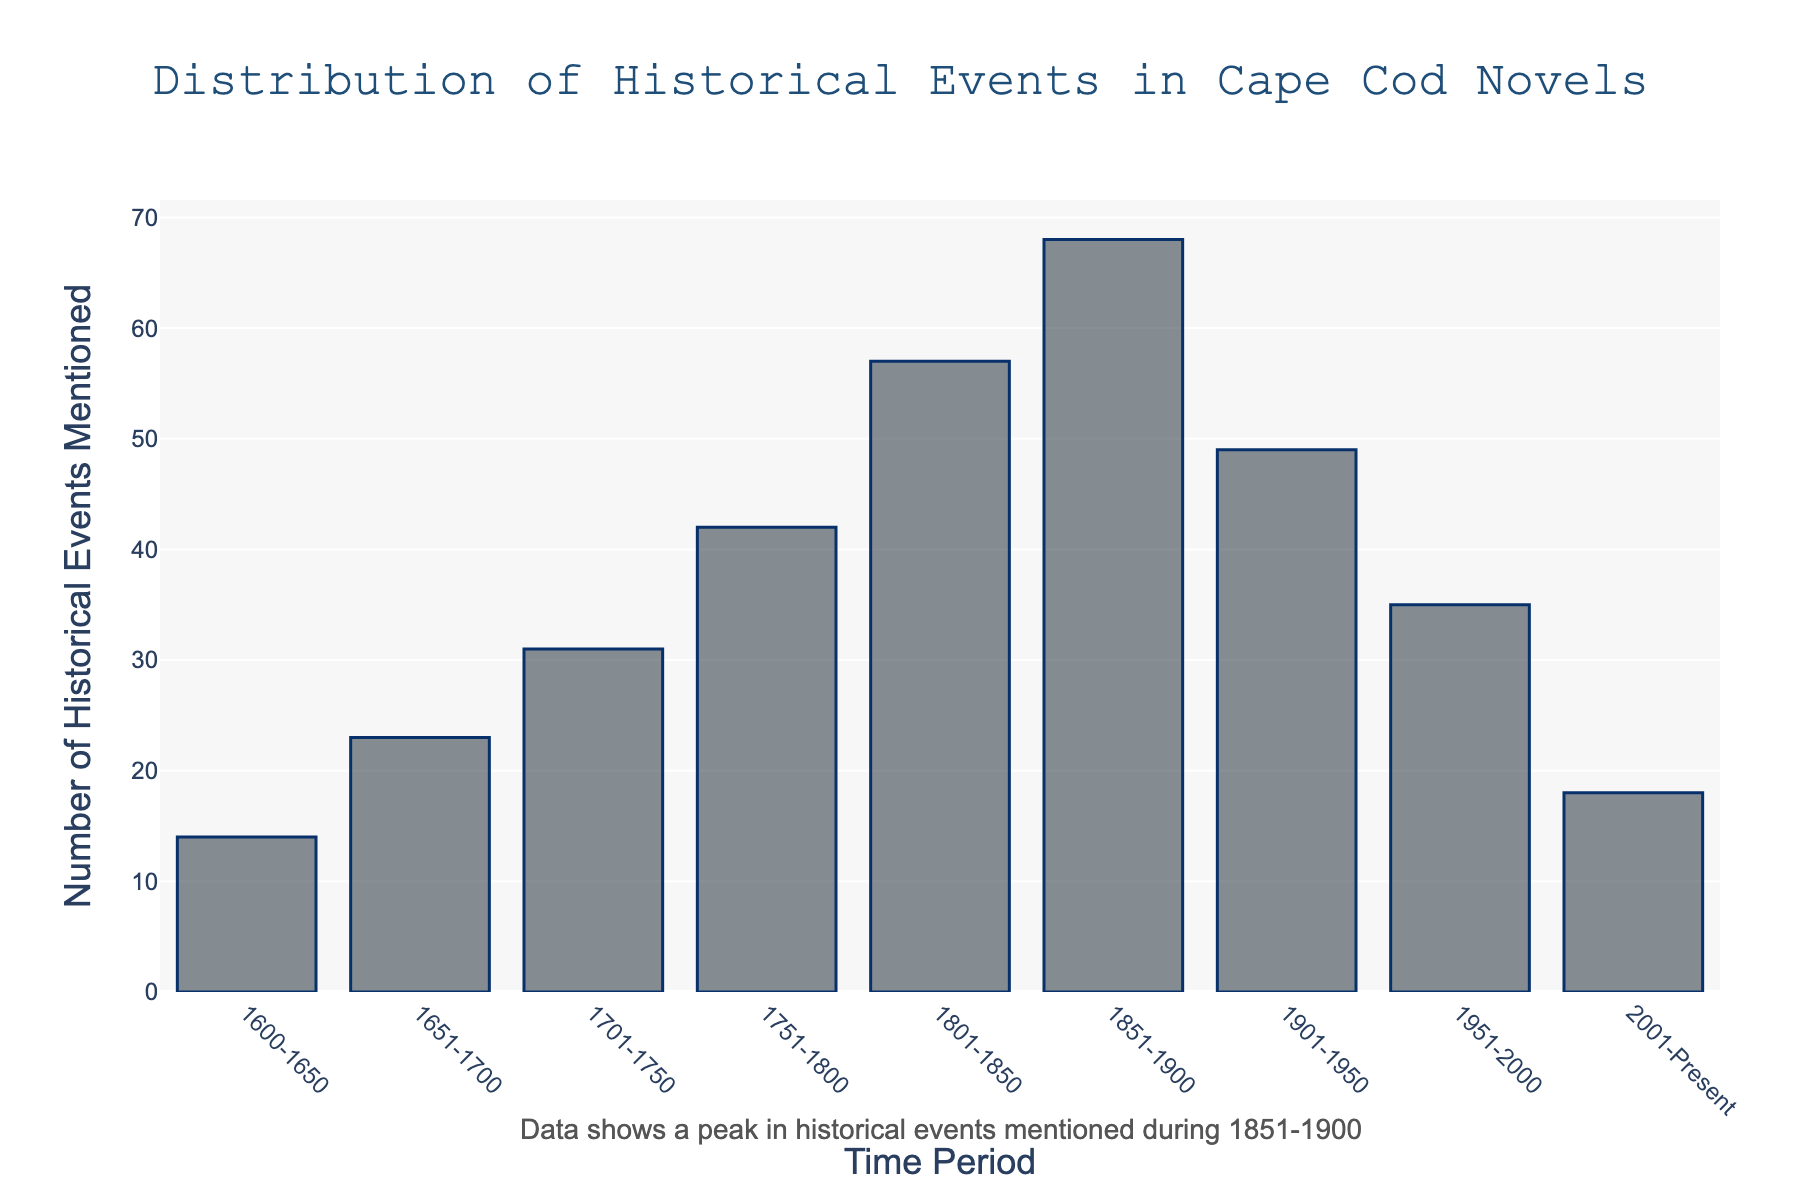What time period has the highest number of historical events mentioned? First, identify the bars with the highest value in the chart. The bar corresponding to the time period 1851-1900 is the tallest, indicating the highest number of events.
Answer: 1851-1900 Which two consecutive time periods have the largest increase in the number of historical events mentioned? Calculate the difference in the number of events between consecutive periods. Check which pair has the largest increase. Comparing the numbers, the increase from 1801-1850 (57 events) to 1851-1900 (68 events) is 11 events, which is the largest.
Answer: 1801-1850 to 1851-1900 What is the total number of historical events mentioned from 1751 to 1900? Sum the events mentioned in the periods 1751-1800, 1801-1850, and 1851-1900. That is 42 (1751-1800) + 57 (1801-1850) + 68 (1851-1900) = 167.
Answer: 167 Which time period has the fewest historical events mentioned, and how many are mentioned? Identify the shortest bar. The period 1600-1650 has the fewest with 14 events mentioned.
Answer: 1600-1650, 14 By how much did the number of historical events mentioned increase from 1701-1750 to 1751-1800? Subtract the number of events in 1701-1750 from 1751-1800. That is 42 (1751-1800) - 31 (1701-1750) = 11.
Answer: 11 What percentage of all mentioned historical events occurred before 1900? First, find the total number of events before 1900 by summing the first six periods: 14 + 23 + 31 + 42 + 57 + 68 = 235. Then, calculate the total number of events in all periods: 14 + 23 + 31 + 42 + 57 + 68 + 49 + 35 + 18 = 337. Finally, divide the total before 1900 by the overall total and multiply by 100: (235 / 337) * 100 ≈ 69.7%.
Answer: 69.7% How does the number of historical events mentioned in the period 1951-2000 compare to 2001-Present? The number of events in 1951-2000 is 35, and for 2001-Present, it is 18. Compare these two numbers: 35 is nearly twice 18.
Answer: 1951-2000 has nearly twice as many events What is the approximate average number of historical events mentioned per time period? First, find the total number of historical events mentioned: 337. Then, divide this by the number of time periods (9): 337 / 9 ≈ 37.4.
Answer: 37.4 Which periods have an above-average number of historical events mentioned? The average number of events is approximately 37.4. Compare each period's number to this value: 
1600-1650 (14), 1651-1700 (23), 1701-1750 (31), 1751-1800 (42), 1801-1850 (57), 1851-1900 (68), 1901-1950 (49), 1951-2000 (35), 2001-Present (18). Periods with above-average events are 1751-1800, 1801-1850, 1851-1900, and 1901-1950.
Answer: 1751-1800, 1801-1850, 1851-1900, 1901-1950 